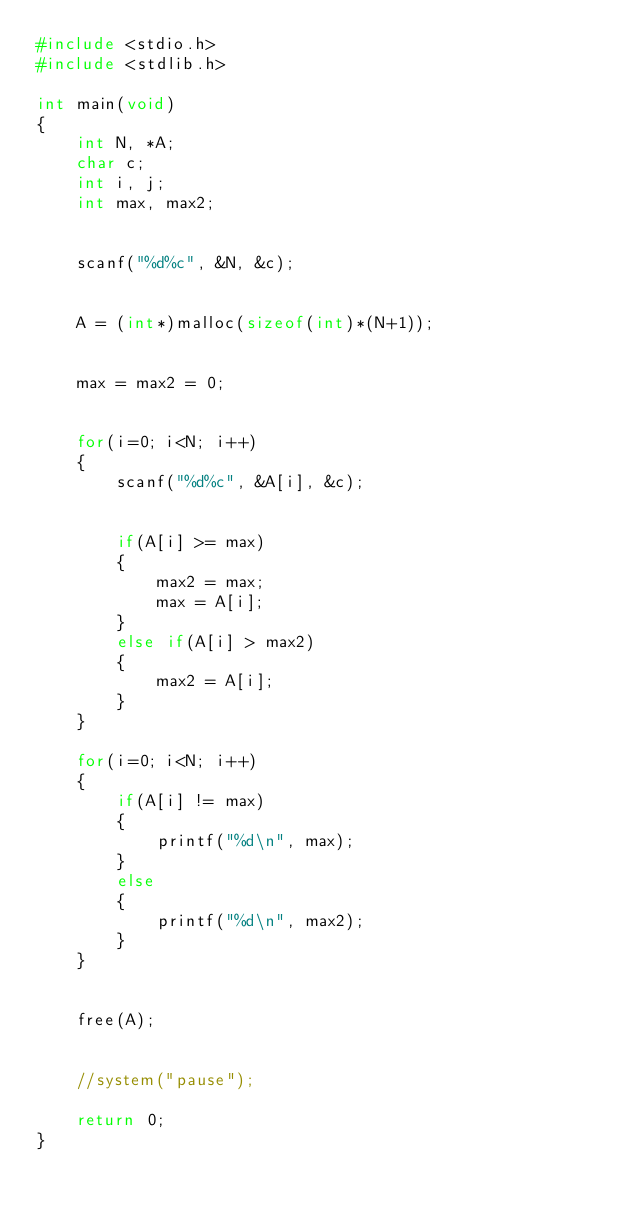Convert code to text. <code><loc_0><loc_0><loc_500><loc_500><_C_>#include <stdio.h>
#include <stdlib.h>

int main(void)
{
    int N, *A;
    char c;
    int i, j;
    int max, max2;
    
    
    scanf("%d%c", &N, &c);
    
    
    A = (int*)malloc(sizeof(int)*(N+1));
    
    
    max = max2 = 0;
    
    
    for(i=0; i<N; i++)
    {
        scanf("%d%c", &A[i], &c);
        
        
        if(A[i] >= max)
        {
            max2 = max;
            max = A[i];
        }
        else if(A[i] > max2)
        {
            max2 = A[i];
        }
    }
    
    for(i=0; i<N; i++)
    {
        if(A[i] != max)
        {
            printf("%d\n", max);
        }
        else
        {
            printf("%d\n", max2);
        }
    }
    
    
    free(A);
    
    
    //system("pause");
    
    return 0;
}
</code> 